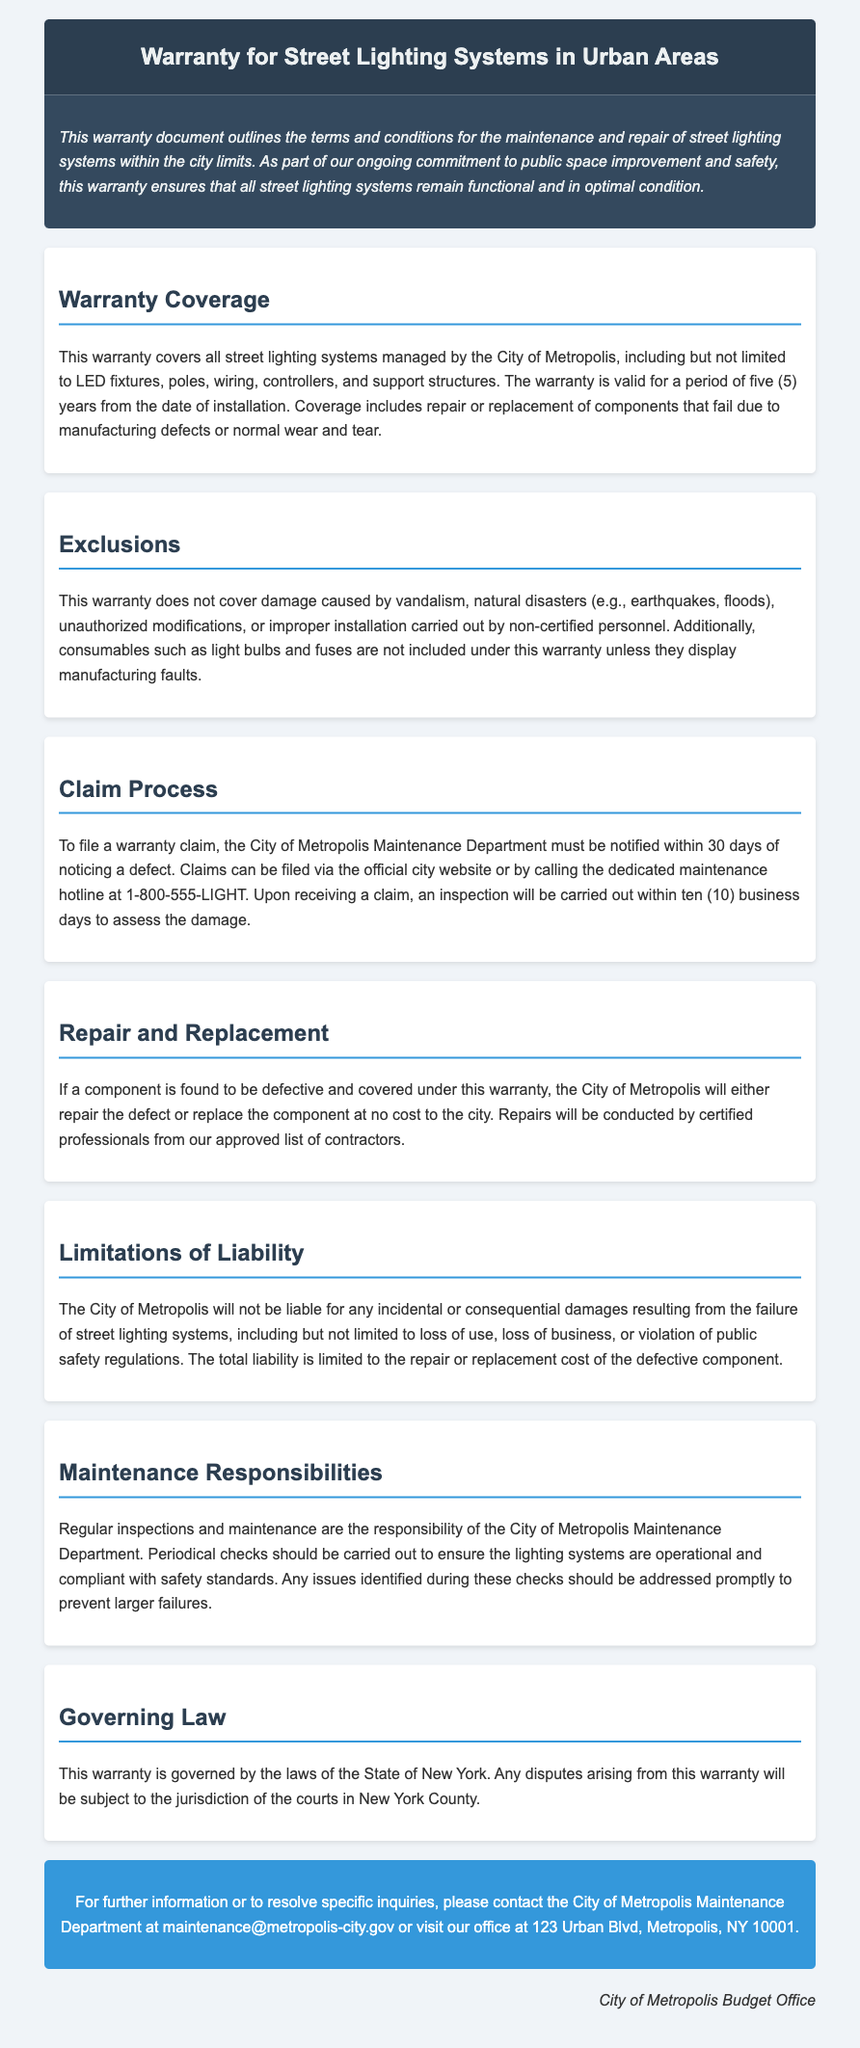What is the warranty period? The warranty period is specified in the document as a duration of five years from the date of installation.
Answer: five (5) years What components are covered under the warranty? The document specifies that the warranty covers LED fixtures, poles, wiring, controllers, and support structures managed by the City of Metropolis.
Answer: LED fixtures, poles, wiring, controllers, and support structures Who is responsible for the maintenance checks? According to the document, the City of Metropolis Maintenance Department is responsible for regular inspections and maintenance of the lighting systems.
Answer: City of Metropolis Maintenance Department What is excluded from the warranty? The document states that damage caused by vandalism, natural disasters, unauthorized modifications, or improper installation is excluded from the warranty.
Answer: vandalism, natural disasters, unauthorized modifications, improper installation How long does one have to notify about a defect? The document mentions that the City of Metropolis Maintenance Department must be notified within 30 days of noticing a defect.
Answer: 30 days What is the contact email for the maintenance department? The document provides the contact email for the maintenance department, ensuring quick communication for inquiries.
Answer: maintenance@metropolis-city.gov Under what law is the warranty governed? The document states that the warranty is governed by the laws of the State of New York.
Answer: State of New York What is the liability limitation specified in the warranty? The document specifies that the total liability is limited to the repair or replacement cost of the defective component.
Answer: repair or replacement cost of the defective component 